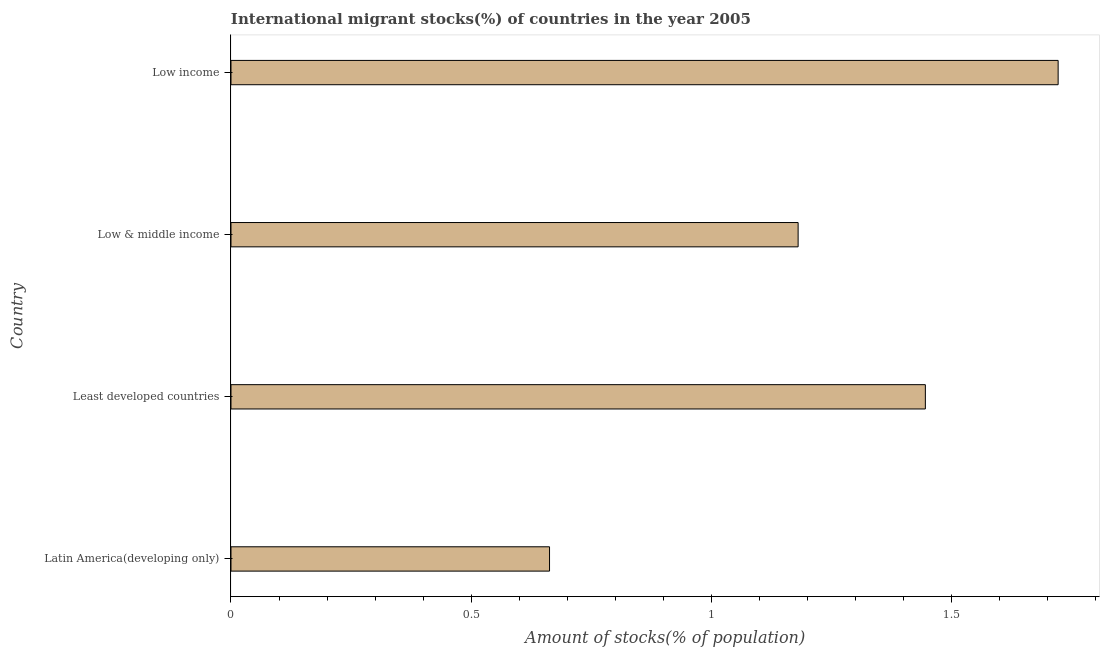Does the graph contain any zero values?
Provide a short and direct response. No. What is the title of the graph?
Ensure brevity in your answer.  International migrant stocks(%) of countries in the year 2005. What is the label or title of the X-axis?
Provide a succinct answer. Amount of stocks(% of population). What is the number of international migrant stocks in Least developed countries?
Your response must be concise. 1.45. Across all countries, what is the maximum number of international migrant stocks?
Your response must be concise. 1.72. Across all countries, what is the minimum number of international migrant stocks?
Your answer should be very brief. 0.66. In which country was the number of international migrant stocks minimum?
Make the answer very short. Latin America(developing only). What is the sum of the number of international migrant stocks?
Make the answer very short. 5.01. What is the difference between the number of international migrant stocks in Latin America(developing only) and Low & middle income?
Give a very brief answer. -0.52. What is the average number of international migrant stocks per country?
Your response must be concise. 1.25. What is the median number of international migrant stocks?
Ensure brevity in your answer.  1.31. In how many countries, is the number of international migrant stocks greater than 0.8 %?
Make the answer very short. 3. What is the ratio of the number of international migrant stocks in Least developed countries to that in Low income?
Provide a succinct answer. 0.84. What is the difference between the highest and the second highest number of international migrant stocks?
Offer a terse response. 0.28. Is the sum of the number of international migrant stocks in Latin America(developing only) and Least developed countries greater than the maximum number of international migrant stocks across all countries?
Keep it short and to the point. Yes. What is the difference between the highest and the lowest number of international migrant stocks?
Your answer should be compact. 1.06. How many bars are there?
Ensure brevity in your answer.  4. Are all the bars in the graph horizontal?
Make the answer very short. Yes. What is the Amount of stocks(% of population) of Latin America(developing only)?
Your answer should be very brief. 0.66. What is the Amount of stocks(% of population) of Least developed countries?
Provide a succinct answer. 1.45. What is the Amount of stocks(% of population) of Low & middle income?
Provide a short and direct response. 1.18. What is the Amount of stocks(% of population) of Low income?
Offer a very short reply. 1.72. What is the difference between the Amount of stocks(% of population) in Latin America(developing only) and Least developed countries?
Provide a short and direct response. -0.78. What is the difference between the Amount of stocks(% of population) in Latin America(developing only) and Low & middle income?
Provide a short and direct response. -0.52. What is the difference between the Amount of stocks(% of population) in Latin America(developing only) and Low income?
Your answer should be compact. -1.06. What is the difference between the Amount of stocks(% of population) in Least developed countries and Low & middle income?
Make the answer very short. 0.26. What is the difference between the Amount of stocks(% of population) in Least developed countries and Low income?
Provide a succinct answer. -0.28. What is the difference between the Amount of stocks(% of population) in Low & middle income and Low income?
Offer a terse response. -0.54. What is the ratio of the Amount of stocks(% of population) in Latin America(developing only) to that in Least developed countries?
Your response must be concise. 0.46. What is the ratio of the Amount of stocks(% of population) in Latin America(developing only) to that in Low & middle income?
Provide a succinct answer. 0.56. What is the ratio of the Amount of stocks(% of population) in Latin America(developing only) to that in Low income?
Your answer should be compact. 0.39. What is the ratio of the Amount of stocks(% of population) in Least developed countries to that in Low & middle income?
Your response must be concise. 1.22. What is the ratio of the Amount of stocks(% of population) in Least developed countries to that in Low income?
Your answer should be very brief. 0.84. What is the ratio of the Amount of stocks(% of population) in Low & middle income to that in Low income?
Your response must be concise. 0.69. 